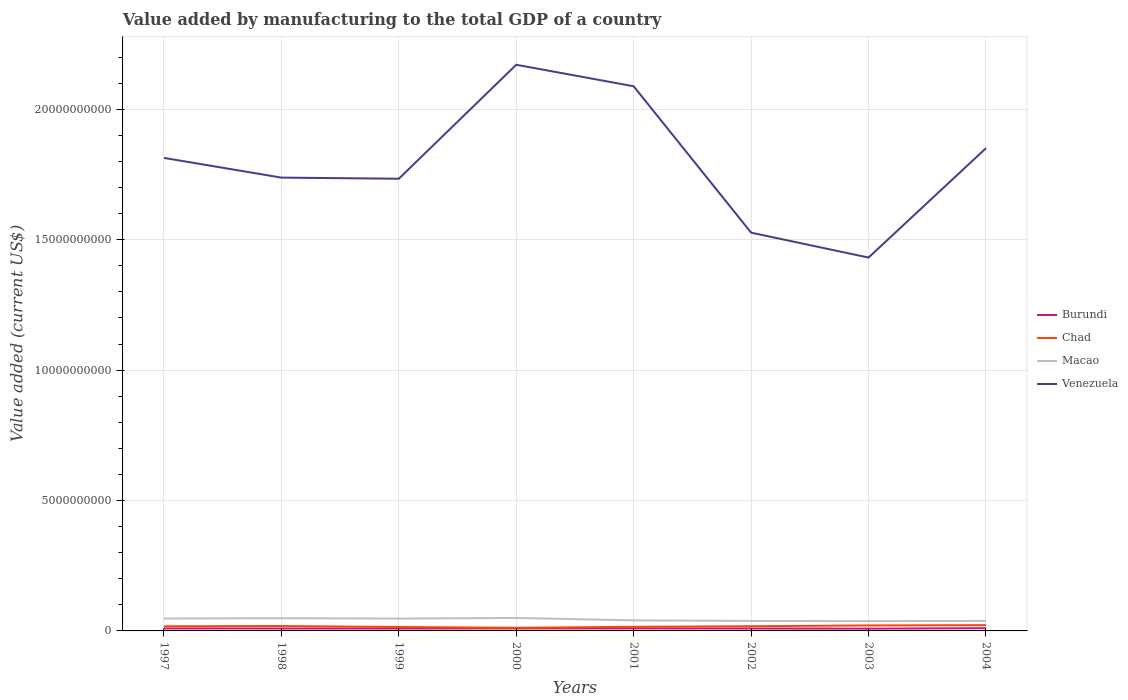Does the line corresponding to Venezuela intersect with the line corresponding to Burundi?
Ensure brevity in your answer.  No. Is the number of lines equal to the number of legend labels?
Ensure brevity in your answer.  Yes. Across all years, what is the maximum value added by manufacturing to the total GDP in Chad?
Your answer should be compact. 1.19e+08. In which year was the value added by manufacturing to the total GDP in Venezuela maximum?
Make the answer very short. 2003. What is the total value added by manufacturing to the total GDP in Macao in the graph?
Provide a short and direct response. 8.84e+07. What is the difference between the highest and the second highest value added by manufacturing to the total GDP in Burundi?
Keep it short and to the point. 1.82e+07. What is the difference between the highest and the lowest value added by manufacturing to the total GDP in Burundi?
Your answer should be compact. 4. How many lines are there?
Make the answer very short. 4. Are the values on the major ticks of Y-axis written in scientific E-notation?
Keep it short and to the point. No. Where does the legend appear in the graph?
Keep it short and to the point. Center right. How are the legend labels stacked?
Make the answer very short. Vertical. What is the title of the graph?
Offer a terse response. Value added by manufacturing to the total GDP of a country. What is the label or title of the Y-axis?
Make the answer very short. Value added (current US$). What is the Value added (current US$) of Burundi in 1997?
Make the answer very short. 9.48e+07. What is the Value added (current US$) of Chad in 1997?
Provide a short and direct response. 1.78e+08. What is the Value added (current US$) in Macao in 1997?
Give a very brief answer. 4.75e+08. What is the Value added (current US$) of Venezuela in 1997?
Your answer should be compact. 1.81e+1. What is the Value added (current US$) of Burundi in 1998?
Keep it short and to the point. 9.21e+07. What is the Value added (current US$) in Chad in 1998?
Provide a succinct answer. 1.88e+08. What is the Value added (current US$) of Macao in 1998?
Provide a short and direct response. 4.88e+08. What is the Value added (current US$) of Venezuela in 1998?
Your answer should be very brief. 1.74e+1. What is the Value added (current US$) in Burundi in 1999?
Your answer should be compact. 9.14e+07. What is the Value added (current US$) in Chad in 1999?
Your answer should be compact. 1.50e+08. What is the Value added (current US$) of Macao in 1999?
Make the answer very short. 4.73e+08. What is the Value added (current US$) of Venezuela in 1999?
Provide a succinct answer. 1.73e+1. What is the Value added (current US$) in Burundi in 2000?
Provide a short and direct response. 9.49e+07. What is the Value added (current US$) in Chad in 2000?
Your answer should be compact. 1.19e+08. What is the Value added (current US$) of Macao in 2000?
Your response must be concise. 4.97e+08. What is the Value added (current US$) in Venezuela in 2000?
Provide a succinct answer. 2.17e+1. What is the Value added (current US$) in Burundi in 2001?
Ensure brevity in your answer.  9.58e+07. What is the Value added (current US$) in Chad in 2001?
Offer a terse response. 1.57e+08. What is the Value added (current US$) of Macao in 2001?
Provide a short and direct response. 4.05e+08. What is the Value added (current US$) of Venezuela in 2001?
Make the answer very short. 2.09e+1. What is the Value added (current US$) of Burundi in 2002?
Your answer should be compact. 9.15e+07. What is the Value added (current US$) in Chad in 2002?
Give a very brief answer. 1.80e+08. What is the Value added (current US$) of Macao in 2002?
Your response must be concise. 3.82e+08. What is the Value added (current US$) in Venezuela in 2002?
Give a very brief answer. 1.53e+1. What is the Value added (current US$) of Burundi in 2003?
Your answer should be compact. 8.66e+07. What is the Value added (current US$) of Chad in 2003?
Your answer should be compact. 2.10e+08. What is the Value added (current US$) of Macao in 2003?
Make the answer very short. 3.75e+08. What is the Value added (current US$) of Venezuela in 2003?
Keep it short and to the point. 1.43e+1. What is the Value added (current US$) in Burundi in 2004?
Offer a very short reply. 1.05e+08. What is the Value added (current US$) of Chad in 2004?
Your answer should be very brief. 2.22e+08. What is the Value added (current US$) of Macao in 2004?
Give a very brief answer. 3.84e+08. What is the Value added (current US$) of Venezuela in 2004?
Your answer should be compact. 1.85e+1. Across all years, what is the maximum Value added (current US$) of Burundi?
Provide a succinct answer. 1.05e+08. Across all years, what is the maximum Value added (current US$) of Chad?
Make the answer very short. 2.22e+08. Across all years, what is the maximum Value added (current US$) of Macao?
Your response must be concise. 4.97e+08. Across all years, what is the maximum Value added (current US$) of Venezuela?
Keep it short and to the point. 2.17e+1. Across all years, what is the minimum Value added (current US$) in Burundi?
Give a very brief answer. 8.66e+07. Across all years, what is the minimum Value added (current US$) of Chad?
Keep it short and to the point. 1.19e+08. Across all years, what is the minimum Value added (current US$) in Macao?
Keep it short and to the point. 3.75e+08. Across all years, what is the minimum Value added (current US$) of Venezuela?
Make the answer very short. 1.43e+1. What is the total Value added (current US$) of Burundi in the graph?
Provide a short and direct response. 7.52e+08. What is the total Value added (current US$) in Chad in the graph?
Your answer should be very brief. 1.40e+09. What is the total Value added (current US$) of Macao in the graph?
Your response must be concise. 3.48e+09. What is the total Value added (current US$) in Venezuela in the graph?
Make the answer very short. 1.44e+11. What is the difference between the Value added (current US$) in Burundi in 1997 and that in 1998?
Give a very brief answer. 2.69e+06. What is the difference between the Value added (current US$) of Chad in 1997 and that in 1998?
Provide a short and direct response. -9.75e+06. What is the difference between the Value added (current US$) of Macao in 1997 and that in 1998?
Ensure brevity in your answer.  -1.30e+07. What is the difference between the Value added (current US$) of Venezuela in 1997 and that in 1998?
Your answer should be very brief. 7.56e+08. What is the difference between the Value added (current US$) of Burundi in 1997 and that in 1999?
Provide a short and direct response. 3.42e+06. What is the difference between the Value added (current US$) in Chad in 1997 and that in 1999?
Your response must be concise. 2.82e+07. What is the difference between the Value added (current US$) in Macao in 1997 and that in 1999?
Your answer should be compact. 1.82e+06. What is the difference between the Value added (current US$) in Venezuela in 1997 and that in 1999?
Provide a short and direct response. 7.99e+08. What is the difference between the Value added (current US$) of Burundi in 1997 and that in 2000?
Keep it short and to the point. -9.14e+04. What is the difference between the Value added (current US$) in Chad in 1997 and that in 2000?
Provide a short and direct response. 5.94e+07. What is the difference between the Value added (current US$) of Macao in 1997 and that in 2000?
Give a very brief answer. -2.24e+07. What is the difference between the Value added (current US$) of Venezuela in 1997 and that in 2000?
Your answer should be compact. -3.57e+09. What is the difference between the Value added (current US$) in Burundi in 1997 and that in 2001?
Keep it short and to the point. -9.86e+05. What is the difference between the Value added (current US$) of Chad in 1997 and that in 2001?
Provide a succinct answer. 2.09e+07. What is the difference between the Value added (current US$) of Macao in 1997 and that in 2001?
Provide a succinct answer. 6.96e+07. What is the difference between the Value added (current US$) in Venezuela in 1997 and that in 2001?
Your answer should be very brief. -2.75e+09. What is the difference between the Value added (current US$) of Burundi in 1997 and that in 2002?
Offer a very short reply. 3.29e+06. What is the difference between the Value added (current US$) of Chad in 1997 and that in 2002?
Keep it short and to the point. -1.81e+06. What is the difference between the Value added (current US$) in Macao in 1997 and that in 2002?
Ensure brevity in your answer.  9.26e+07. What is the difference between the Value added (current US$) in Venezuela in 1997 and that in 2002?
Provide a succinct answer. 2.87e+09. What is the difference between the Value added (current US$) in Burundi in 1997 and that in 2003?
Provide a short and direct response. 8.15e+06. What is the difference between the Value added (current US$) of Chad in 1997 and that in 2003?
Provide a short and direct response. -3.16e+07. What is the difference between the Value added (current US$) of Macao in 1997 and that in 2003?
Keep it short and to the point. 9.95e+07. What is the difference between the Value added (current US$) in Venezuela in 1997 and that in 2003?
Give a very brief answer. 3.82e+09. What is the difference between the Value added (current US$) of Burundi in 1997 and that in 2004?
Provide a succinct answer. -1.00e+07. What is the difference between the Value added (current US$) in Chad in 1997 and that in 2004?
Ensure brevity in your answer.  -4.33e+07. What is the difference between the Value added (current US$) in Macao in 1997 and that in 2004?
Make the answer very short. 9.02e+07. What is the difference between the Value added (current US$) in Venezuela in 1997 and that in 2004?
Ensure brevity in your answer.  -3.71e+08. What is the difference between the Value added (current US$) in Burundi in 1998 and that in 1999?
Provide a succinct answer. 7.35e+05. What is the difference between the Value added (current US$) of Chad in 1998 and that in 1999?
Give a very brief answer. 3.80e+07. What is the difference between the Value added (current US$) in Macao in 1998 and that in 1999?
Give a very brief answer. 1.48e+07. What is the difference between the Value added (current US$) of Venezuela in 1998 and that in 1999?
Provide a succinct answer. 4.28e+07. What is the difference between the Value added (current US$) in Burundi in 1998 and that in 2000?
Your answer should be compact. -2.78e+06. What is the difference between the Value added (current US$) of Chad in 1998 and that in 2000?
Offer a very short reply. 6.91e+07. What is the difference between the Value added (current US$) of Macao in 1998 and that in 2000?
Keep it short and to the point. -9.37e+06. What is the difference between the Value added (current US$) of Venezuela in 1998 and that in 2000?
Offer a terse response. -4.33e+09. What is the difference between the Value added (current US$) of Burundi in 1998 and that in 2001?
Your answer should be very brief. -3.67e+06. What is the difference between the Value added (current US$) in Chad in 1998 and that in 2001?
Offer a very short reply. 3.06e+07. What is the difference between the Value added (current US$) in Macao in 1998 and that in 2001?
Provide a succinct answer. 8.26e+07. What is the difference between the Value added (current US$) in Venezuela in 1998 and that in 2001?
Ensure brevity in your answer.  -3.50e+09. What is the difference between the Value added (current US$) of Burundi in 1998 and that in 2002?
Your answer should be compact. 6.04e+05. What is the difference between the Value added (current US$) of Chad in 1998 and that in 2002?
Keep it short and to the point. 7.94e+06. What is the difference between the Value added (current US$) of Macao in 1998 and that in 2002?
Provide a short and direct response. 1.06e+08. What is the difference between the Value added (current US$) of Venezuela in 1998 and that in 2002?
Keep it short and to the point. 2.11e+09. What is the difference between the Value added (current US$) in Burundi in 1998 and that in 2003?
Your answer should be compact. 5.46e+06. What is the difference between the Value added (current US$) of Chad in 1998 and that in 2003?
Offer a terse response. -2.19e+07. What is the difference between the Value added (current US$) of Macao in 1998 and that in 2003?
Offer a very short reply. 1.12e+08. What is the difference between the Value added (current US$) in Venezuela in 1998 and that in 2003?
Keep it short and to the point. 3.07e+09. What is the difference between the Value added (current US$) in Burundi in 1998 and that in 2004?
Offer a terse response. -1.27e+07. What is the difference between the Value added (current US$) of Chad in 1998 and that in 2004?
Make the answer very short. -3.36e+07. What is the difference between the Value added (current US$) of Macao in 1998 and that in 2004?
Make the answer very short. 1.03e+08. What is the difference between the Value added (current US$) of Venezuela in 1998 and that in 2004?
Offer a terse response. -1.13e+09. What is the difference between the Value added (current US$) of Burundi in 1999 and that in 2000?
Your response must be concise. -3.52e+06. What is the difference between the Value added (current US$) of Chad in 1999 and that in 2000?
Your response must be concise. 3.12e+07. What is the difference between the Value added (current US$) in Macao in 1999 and that in 2000?
Your answer should be compact. -2.42e+07. What is the difference between the Value added (current US$) in Venezuela in 1999 and that in 2000?
Provide a succinct answer. -4.37e+09. What is the difference between the Value added (current US$) in Burundi in 1999 and that in 2001?
Your answer should be very brief. -4.41e+06. What is the difference between the Value added (current US$) in Chad in 1999 and that in 2001?
Provide a short and direct response. -7.35e+06. What is the difference between the Value added (current US$) in Macao in 1999 and that in 2001?
Offer a very short reply. 6.78e+07. What is the difference between the Value added (current US$) in Venezuela in 1999 and that in 2001?
Ensure brevity in your answer.  -3.54e+09. What is the difference between the Value added (current US$) in Burundi in 1999 and that in 2002?
Offer a very short reply. -1.31e+05. What is the difference between the Value added (current US$) of Chad in 1999 and that in 2002?
Make the answer very short. -3.00e+07. What is the difference between the Value added (current US$) in Macao in 1999 and that in 2002?
Your answer should be very brief. 9.07e+07. What is the difference between the Value added (current US$) of Venezuela in 1999 and that in 2002?
Provide a short and direct response. 2.07e+09. What is the difference between the Value added (current US$) in Burundi in 1999 and that in 2003?
Provide a succinct answer. 4.73e+06. What is the difference between the Value added (current US$) in Chad in 1999 and that in 2003?
Your answer should be very brief. -5.98e+07. What is the difference between the Value added (current US$) in Macao in 1999 and that in 2003?
Provide a short and direct response. 9.76e+07. What is the difference between the Value added (current US$) in Venezuela in 1999 and that in 2003?
Offer a very short reply. 3.02e+09. What is the difference between the Value added (current US$) in Burundi in 1999 and that in 2004?
Offer a terse response. -1.34e+07. What is the difference between the Value added (current US$) of Chad in 1999 and that in 2004?
Your answer should be very brief. -7.16e+07. What is the difference between the Value added (current US$) in Macao in 1999 and that in 2004?
Your answer should be very brief. 8.84e+07. What is the difference between the Value added (current US$) of Venezuela in 1999 and that in 2004?
Keep it short and to the point. -1.17e+09. What is the difference between the Value added (current US$) of Burundi in 2000 and that in 2001?
Provide a short and direct response. -8.95e+05. What is the difference between the Value added (current US$) of Chad in 2000 and that in 2001?
Offer a terse response. -3.85e+07. What is the difference between the Value added (current US$) in Macao in 2000 and that in 2001?
Your answer should be compact. 9.20e+07. What is the difference between the Value added (current US$) of Venezuela in 2000 and that in 2001?
Offer a very short reply. 8.25e+08. What is the difference between the Value added (current US$) in Burundi in 2000 and that in 2002?
Offer a very short reply. 3.38e+06. What is the difference between the Value added (current US$) in Chad in 2000 and that in 2002?
Your answer should be compact. -6.12e+07. What is the difference between the Value added (current US$) of Macao in 2000 and that in 2002?
Your answer should be compact. 1.15e+08. What is the difference between the Value added (current US$) of Venezuela in 2000 and that in 2002?
Keep it short and to the point. 6.44e+09. What is the difference between the Value added (current US$) in Burundi in 2000 and that in 2003?
Your answer should be compact. 8.24e+06. What is the difference between the Value added (current US$) in Chad in 2000 and that in 2003?
Offer a terse response. -9.10e+07. What is the difference between the Value added (current US$) in Macao in 2000 and that in 2003?
Give a very brief answer. 1.22e+08. What is the difference between the Value added (current US$) of Venezuela in 2000 and that in 2003?
Ensure brevity in your answer.  7.39e+09. What is the difference between the Value added (current US$) in Burundi in 2000 and that in 2004?
Keep it short and to the point. -9.91e+06. What is the difference between the Value added (current US$) in Chad in 2000 and that in 2004?
Ensure brevity in your answer.  -1.03e+08. What is the difference between the Value added (current US$) of Macao in 2000 and that in 2004?
Offer a terse response. 1.13e+08. What is the difference between the Value added (current US$) of Venezuela in 2000 and that in 2004?
Provide a succinct answer. 3.20e+09. What is the difference between the Value added (current US$) of Burundi in 2001 and that in 2002?
Ensure brevity in your answer.  4.28e+06. What is the difference between the Value added (current US$) of Chad in 2001 and that in 2002?
Offer a very short reply. -2.27e+07. What is the difference between the Value added (current US$) in Macao in 2001 and that in 2002?
Provide a succinct answer. 2.30e+07. What is the difference between the Value added (current US$) in Venezuela in 2001 and that in 2002?
Offer a very short reply. 5.61e+09. What is the difference between the Value added (current US$) in Burundi in 2001 and that in 2003?
Ensure brevity in your answer.  9.14e+06. What is the difference between the Value added (current US$) in Chad in 2001 and that in 2003?
Offer a very short reply. -5.25e+07. What is the difference between the Value added (current US$) of Macao in 2001 and that in 2003?
Make the answer very short. 2.99e+07. What is the difference between the Value added (current US$) in Venezuela in 2001 and that in 2003?
Offer a very short reply. 6.57e+09. What is the difference between the Value added (current US$) of Burundi in 2001 and that in 2004?
Your answer should be compact. -9.02e+06. What is the difference between the Value added (current US$) in Chad in 2001 and that in 2004?
Keep it short and to the point. -6.42e+07. What is the difference between the Value added (current US$) of Macao in 2001 and that in 2004?
Offer a very short reply. 2.06e+07. What is the difference between the Value added (current US$) of Venezuela in 2001 and that in 2004?
Keep it short and to the point. 2.37e+09. What is the difference between the Value added (current US$) in Burundi in 2002 and that in 2003?
Your response must be concise. 4.86e+06. What is the difference between the Value added (current US$) of Chad in 2002 and that in 2003?
Ensure brevity in your answer.  -2.98e+07. What is the difference between the Value added (current US$) in Macao in 2002 and that in 2003?
Your answer should be very brief. 6.90e+06. What is the difference between the Value added (current US$) in Venezuela in 2002 and that in 2003?
Provide a short and direct response. 9.55e+08. What is the difference between the Value added (current US$) of Burundi in 2002 and that in 2004?
Make the answer very short. -1.33e+07. What is the difference between the Value added (current US$) in Chad in 2002 and that in 2004?
Your response must be concise. -4.15e+07. What is the difference between the Value added (current US$) of Macao in 2002 and that in 2004?
Ensure brevity in your answer.  -2.38e+06. What is the difference between the Value added (current US$) in Venezuela in 2002 and that in 2004?
Provide a succinct answer. -3.24e+09. What is the difference between the Value added (current US$) of Burundi in 2003 and that in 2004?
Your answer should be very brief. -1.82e+07. What is the difference between the Value added (current US$) of Chad in 2003 and that in 2004?
Make the answer very short. -1.17e+07. What is the difference between the Value added (current US$) in Macao in 2003 and that in 2004?
Offer a terse response. -9.28e+06. What is the difference between the Value added (current US$) in Venezuela in 2003 and that in 2004?
Your response must be concise. -4.19e+09. What is the difference between the Value added (current US$) of Burundi in 1997 and the Value added (current US$) of Chad in 1998?
Ensure brevity in your answer.  -9.33e+07. What is the difference between the Value added (current US$) of Burundi in 1997 and the Value added (current US$) of Macao in 1998?
Offer a very short reply. -3.93e+08. What is the difference between the Value added (current US$) of Burundi in 1997 and the Value added (current US$) of Venezuela in 1998?
Offer a very short reply. -1.73e+1. What is the difference between the Value added (current US$) of Chad in 1997 and the Value added (current US$) of Macao in 1998?
Provide a short and direct response. -3.09e+08. What is the difference between the Value added (current US$) in Chad in 1997 and the Value added (current US$) in Venezuela in 1998?
Keep it short and to the point. -1.72e+1. What is the difference between the Value added (current US$) of Macao in 1997 and the Value added (current US$) of Venezuela in 1998?
Keep it short and to the point. -1.69e+1. What is the difference between the Value added (current US$) in Burundi in 1997 and the Value added (current US$) in Chad in 1999?
Offer a very short reply. -5.53e+07. What is the difference between the Value added (current US$) in Burundi in 1997 and the Value added (current US$) in Macao in 1999?
Provide a succinct answer. -3.78e+08. What is the difference between the Value added (current US$) of Burundi in 1997 and the Value added (current US$) of Venezuela in 1999?
Ensure brevity in your answer.  -1.72e+1. What is the difference between the Value added (current US$) in Chad in 1997 and the Value added (current US$) in Macao in 1999?
Keep it short and to the point. -2.94e+08. What is the difference between the Value added (current US$) of Chad in 1997 and the Value added (current US$) of Venezuela in 1999?
Your answer should be compact. -1.72e+1. What is the difference between the Value added (current US$) in Macao in 1997 and the Value added (current US$) in Venezuela in 1999?
Offer a terse response. -1.69e+1. What is the difference between the Value added (current US$) in Burundi in 1997 and the Value added (current US$) in Chad in 2000?
Provide a succinct answer. -2.41e+07. What is the difference between the Value added (current US$) of Burundi in 1997 and the Value added (current US$) of Macao in 2000?
Ensure brevity in your answer.  -4.02e+08. What is the difference between the Value added (current US$) of Burundi in 1997 and the Value added (current US$) of Venezuela in 2000?
Offer a very short reply. -2.16e+1. What is the difference between the Value added (current US$) in Chad in 1997 and the Value added (current US$) in Macao in 2000?
Give a very brief answer. -3.19e+08. What is the difference between the Value added (current US$) of Chad in 1997 and the Value added (current US$) of Venezuela in 2000?
Make the answer very short. -2.15e+1. What is the difference between the Value added (current US$) of Macao in 1997 and the Value added (current US$) of Venezuela in 2000?
Give a very brief answer. -2.12e+1. What is the difference between the Value added (current US$) in Burundi in 1997 and the Value added (current US$) in Chad in 2001?
Your answer should be very brief. -6.27e+07. What is the difference between the Value added (current US$) of Burundi in 1997 and the Value added (current US$) of Macao in 2001?
Provide a short and direct response. -3.10e+08. What is the difference between the Value added (current US$) of Burundi in 1997 and the Value added (current US$) of Venezuela in 2001?
Keep it short and to the point. -2.08e+1. What is the difference between the Value added (current US$) in Chad in 1997 and the Value added (current US$) in Macao in 2001?
Provide a short and direct response. -2.27e+08. What is the difference between the Value added (current US$) of Chad in 1997 and the Value added (current US$) of Venezuela in 2001?
Offer a very short reply. -2.07e+1. What is the difference between the Value added (current US$) of Macao in 1997 and the Value added (current US$) of Venezuela in 2001?
Keep it short and to the point. -2.04e+1. What is the difference between the Value added (current US$) of Burundi in 1997 and the Value added (current US$) of Chad in 2002?
Provide a succinct answer. -8.53e+07. What is the difference between the Value added (current US$) of Burundi in 1997 and the Value added (current US$) of Macao in 2002?
Make the answer very short. -2.87e+08. What is the difference between the Value added (current US$) in Burundi in 1997 and the Value added (current US$) in Venezuela in 2002?
Provide a succinct answer. -1.52e+1. What is the difference between the Value added (current US$) in Chad in 1997 and the Value added (current US$) in Macao in 2002?
Offer a very short reply. -2.04e+08. What is the difference between the Value added (current US$) in Chad in 1997 and the Value added (current US$) in Venezuela in 2002?
Provide a succinct answer. -1.51e+1. What is the difference between the Value added (current US$) of Macao in 1997 and the Value added (current US$) of Venezuela in 2002?
Make the answer very short. -1.48e+1. What is the difference between the Value added (current US$) of Burundi in 1997 and the Value added (current US$) of Chad in 2003?
Provide a succinct answer. -1.15e+08. What is the difference between the Value added (current US$) of Burundi in 1997 and the Value added (current US$) of Macao in 2003?
Provide a short and direct response. -2.80e+08. What is the difference between the Value added (current US$) of Burundi in 1997 and the Value added (current US$) of Venezuela in 2003?
Ensure brevity in your answer.  -1.42e+1. What is the difference between the Value added (current US$) of Chad in 1997 and the Value added (current US$) of Macao in 2003?
Keep it short and to the point. -1.97e+08. What is the difference between the Value added (current US$) of Chad in 1997 and the Value added (current US$) of Venezuela in 2003?
Provide a succinct answer. -1.41e+1. What is the difference between the Value added (current US$) of Macao in 1997 and the Value added (current US$) of Venezuela in 2003?
Make the answer very short. -1.38e+1. What is the difference between the Value added (current US$) in Burundi in 1997 and the Value added (current US$) in Chad in 2004?
Ensure brevity in your answer.  -1.27e+08. What is the difference between the Value added (current US$) of Burundi in 1997 and the Value added (current US$) of Macao in 2004?
Give a very brief answer. -2.90e+08. What is the difference between the Value added (current US$) in Burundi in 1997 and the Value added (current US$) in Venezuela in 2004?
Your answer should be compact. -1.84e+1. What is the difference between the Value added (current US$) of Chad in 1997 and the Value added (current US$) of Macao in 2004?
Provide a short and direct response. -2.06e+08. What is the difference between the Value added (current US$) of Chad in 1997 and the Value added (current US$) of Venezuela in 2004?
Provide a short and direct response. -1.83e+1. What is the difference between the Value added (current US$) in Macao in 1997 and the Value added (current US$) in Venezuela in 2004?
Offer a terse response. -1.80e+1. What is the difference between the Value added (current US$) of Burundi in 1998 and the Value added (current US$) of Chad in 1999?
Your answer should be compact. -5.80e+07. What is the difference between the Value added (current US$) in Burundi in 1998 and the Value added (current US$) in Macao in 1999?
Your answer should be very brief. -3.81e+08. What is the difference between the Value added (current US$) in Burundi in 1998 and the Value added (current US$) in Venezuela in 1999?
Ensure brevity in your answer.  -1.72e+1. What is the difference between the Value added (current US$) in Chad in 1998 and the Value added (current US$) in Macao in 1999?
Provide a short and direct response. -2.85e+08. What is the difference between the Value added (current US$) of Chad in 1998 and the Value added (current US$) of Venezuela in 1999?
Offer a very short reply. -1.71e+1. What is the difference between the Value added (current US$) in Macao in 1998 and the Value added (current US$) in Venezuela in 1999?
Your response must be concise. -1.68e+1. What is the difference between the Value added (current US$) of Burundi in 1998 and the Value added (current US$) of Chad in 2000?
Offer a terse response. -2.68e+07. What is the difference between the Value added (current US$) of Burundi in 1998 and the Value added (current US$) of Macao in 2000?
Offer a terse response. -4.05e+08. What is the difference between the Value added (current US$) in Burundi in 1998 and the Value added (current US$) in Venezuela in 2000?
Provide a succinct answer. -2.16e+1. What is the difference between the Value added (current US$) of Chad in 1998 and the Value added (current US$) of Macao in 2000?
Offer a very short reply. -3.09e+08. What is the difference between the Value added (current US$) in Chad in 1998 and the Value added (current US$) in Venezuela in 2000?
Keep it short and to the point. -2.15e+1. What is the difference between the Value added (current US$) of Macao in 1998 and the Value added (current US$) of Venezuela in 2000?
Offer a very short reply. -2.12e+1. What is the difference between the Value added (current US$) of Burundi in 1998 and the Value added (current US$) of Chad in 2001?
Offer a very short reply. -6.53e+07. What is the difference between the Value added (current US$) of Burundi in 1998 and the Value added (current US$) of Macao in 2001?
Your answer should be very brief. -3.13e+08. What is the difference between the Value added (current US$) of Burundi in 1998 and the Value added (current US$) of Venezuela in 2001?
Ensure brevity in your answer.  -2.08e+1. What is the difference between the Value added (current US$) in Chad in 1998 and the Value added (current US$) in Macao in 2001?
Give a very brief answer. -2.17e+08. What is the difference between the Value added (current US$) of Chad in 1998 and the Value added (current US$) of Venezuela in 2001?
Give a very brief answer. -2.07e+1. What is the difference between the Value added (current US$) of Macao in 1998 and the Value added (current US$) of Venezuela in 2001?
Your answer should be compact. -2.04e+1. What is the difference between the Value added (current US$) of Burundi in 1998 and the Value added (current US$) of Chad in 2002?
Make the answer very short. -8.80e+07. What is the difference between the Value added (current US$) in Burundi in 1998 and the Value added (current US$) in Macao in 2002?
Offer a terse response. -2.90e+08. What is the difference between the Value added (current US$) in Burundi in 1998 and the Value added (current US$) in Venezuela in 2002?
Your response must be concise. -1.52e+1. What is the difference between the Value added (current US$) in Chad in 1998 and the Value added (current US$) in Macao in 2002?
Offer a terse response. -1.94e+08. What is the difference between the Value added (current US$) in Chad in 1998 and the Value added (current US$) in Venezuela in 2002?
Provide a succinct answer. -1.51e+1. What is the difference between the Value added (current US$) in Macao in 1998 and the Value added (current US$) in Venezuela in 2002?
Ensure brevity in your answer.  -1.48e+1. What is the difference between the Value added (current US$) in Burundi in 1998 and the Value added (current US$) in Chad in 2003?
Offer a very short reply. -1.18e+08. What is the difference between the Value added (current US$) of Burundi in 1998 and the Value added (current US$) of Macao in 2003?
Ensure brevity in your answer.  -2.83e+08. What is the difference between the Value added (current US$) of Burundi in 1998 and the Value added (current US$) of Venezuela in 2003?
Provide a succinct answer. -1.42e+1. What is the difference between the Value added (current US$) in Chad in 1998 and the Value added (current US$) in Macao in 2003?
Your answer should be compact. -1.87e+08. What is the difference between the Value added (current US$) in Chad in 1998 and the Value added (current US$) in Venezuela in 2003?
Make the answer very short. -1.41e+1. What is the difference between the Value added (current US$) in Macao in 1998 and the Value added (current US$) in Venezuela in 2003?
Offer a very short reply. -1.38e+1. What is the difference between the Value added (current US$) of Burundi in 1998 and the Value added (current US$) of Chad in 2004?
Offer a very short reply. -1.30e+08. What is the difference between the Value added (current US$) in Burundi in 1998 and the Value added (current US$) in Macao in 2004?
Your answer should be compact. -2.92e+08. What is the difference between the Value added (current US$) of Burundi in 1998 and the Value added (current US$) of Venezuela in 2004?
Provide a short and direct response. -1.84e+1. What is the difference between the Value added (current US$) in Chad in 1998 and the Value added (current US$) in Macao in 2004?
Your response must be concise. -1.96e+08. What is the difference between the Value added (current US$) of Chad in 1998 and the Value added (current US$) of Venezuela in 2004?
Provide a short and direct response. -1.83e+1. What is the difference between the Value added (current US$) in Macao in 1998 and the Value added (current US$) in Venezuela in 2004?
Your answer should be compact. -1.80e+1. What is the difference between the Value added (current US$) in Burundi in 1999 and the Value added (current US$) in Chad in 2000?
Provide a short and direct response. -2.76e+07. What is the difference between the Value added (current US$) in Burundi in 1999 and the Value added (current US$) in Macao in 2000?
Give a very brief answer. -4.06e+08. What is the difference between the Value added (current US$) in Burundi in 1999 and the Value added (current US$) in Venezuela in 2000?
Give a very brief answer. -2.16e+1. What is the difference between the Value added (current US$) in Chad in 1999 and the Value added (current US$) in Macao in 2000?
Ensure brevity in your answer.  -3.47e+08. What is the difference between the Value added (current US$) in Chad in 1999 and the Value added (current US$) in Venezuela in 2000?
Offer a very short reply. -2.16e+1. What is the difference between the Value added (current US$) of Macao in 1999 and the Value added (current US$) of Venezuela in 2000?
Your answer should be very brief. -2.12e+1. What is the difference between the Value added (current US$) in Burundi in 1999 and the Value added (current US$) in Chad in 2001?
Give a very brief answer. -6.61e+07. What is the difference between the Value added (current US$) of Burundi in 1999 and the Value added (current US$) of Macao in 2001?
Ensure brevity in your answer.  -3.14e+08. What is the difference between the Value added (current US$) of Burundi in 1999 and the Value added (current US$) of Venezuela in 2001?
Your answer should be very brief. -2.08e+1. What is the difference between the Value added (current US$) of Chad in 1999 and the Value added (current US$) of Macao in 2001?
Offer a very short reply. -2.55e+08. What is the difference between the Value added (current US$) in Chad in 1999 and the Value added (current US$) in Venezuela in 2001?
Make the answer very short. -2.07e+1. What is the difference between the Value added (current US$) in Macao in 1999 and the Value added (current US$) in Venezuela in 2001?
Offer a very short reply. -2.04e+1. What is the difference between the Value added (current US$) in Burundi in 1999 and the Value added (current US$) in Chad in 2002?
Your response must be concise. -8.87e+07. What is the difference between the Value added (current US$) in Burundi in 1999 and the Value added (current US$) in Macao in 2002?
Your answer should be very brief. -2.91e+08. What is the difference between the Value added (current US$) in Burundi in 1999 and the Value added (current US$) in Venezuela in 2002?
Your answer should be compact. -1.52e+1. What is the difference between the Value added (current US$) of Chad in 1999 and the Value added (current US$) of Macao in 2002?
Provide a succinct answer. -2.32e+08. What is the difference between the Value added (current US$) in Chad in 1999 and the Value added (current US$) in Venezuela in 2002?
Offer a terse response. -1.51e+1. What is the difference between the Value added (current US$) in Macao in 1999 and the Value added (current US$) in Venezuela in 2002?
Give a very brief answer. -1.48e+1. What is the difference between the Value added (current US$) of Burundi in 1999 and the Value added (current US$) of Chad in 2003?
Ensure brevity in your answer.  -1.19e+08. What is the difference between the Value added (current US$) of Burundi in 1999 and the Value added (current US$) of Macao in 2003?
Make the answer very short. -2.84e+08. What is the difference between the Value added (current US$) in Burundi in 1999 and the Value added (current US$) in Venezuela in 2003?
Ensure brevity in your answer.  -1.42e+1. What is the difference between the Value added (current US$) of Chad in 1999 and the Value added (current US$) of Macao in 2003?
Your answer should be very brief. -2.25e+08. What is the difference between the Value added (current US$) of Chad in 1999 and the Value added (current US$) of Venezuela in 2003?
Provide a succinct answer. -1.42e+1. What is the difference between the Value added (current US$) of Macao in 1999 and the Value added (current US$) of Venezuela in 2003?
Offer a very short reply. -1.38e+1. What is the difference between the Value added (current US$) of Burundi in 1999 and the Value added (current US$) of Chad in 2004?
Your answer should be compact. -1.30e+08. What is the difference between the Value added (current US$) of Burundi in 1999 and the Value added (current US$) of Macao in 2004?
Keep it short and to the point. -2.93e+08. What is the difference between the Value added (current US$) in Burundi in 1999 and the Value added (current US$) in Venezuela in 2004?
Provide a succinct answer. -1.84e+1. What is the difference between the Value added (current US$) in Chad in 1999 and the Value added (current US$) in Macao in 2004?
Give a very brief answer. -2.34e+08. What is the difference between the Value added (current US$) in Chad in 1999 and the Value added (current US$) in Venezuela in 2004?
Your answer should be compact. -1.84e+1. What is the difference between the Value added (current US$) in Macao in 1999 and the Value added (current US$) in Venezuela in 2004?
Your answer should be compact. -1.80e+1. What is the difference between the Value added (current US$) of Burundi in 2000 and the Value added (current US$) of Chad in 2001?
Offer a very short reply. -6.26e+07. What is the difference between the Value added (current US$) in Burundi in 2000 and the Value added (current US$) in Macao in 2001?
Offer a very short reply. -3.10e+08. What is the difference between the Value added (current US$) of Burundi in 2000 and the Value added (current US$) of Venezuela in 2001?
Give a very brief answer. -2.08e+1. What is the difference between the Value added (current US$) in Chad in 2000 and the Value added (current US$) in Macao in 2001?
Your answer should be very brief. -2.86e+08. What is the difference between the Value added (current US$) in Chad in 2000 and the Value added (current US$) in Venezuela in 2001?
Ensure brevity in your answer.  -2.08e+1. What is the difference between the Value added (current US$) of Macao in 2000 and the Value added (current US$) of Venezuela in 2001?
Make the answer very short. -2.04e+1. What is the difference between the Value added (current US$) of Burundi in 2000 and the Value added (current US$) of Chad in 2002?
Your response must be concise. -8.52e+07. What is the difference between the Value added (current US$) of Burundi in 2000 and the Value added (current US$) of Macao in 2002?
Provide a succinct answer. -2.87e+08. What is the difference between the Value added (current US$) of Burundi in 2000 and the Value added (current US$) of Venezuela in 2002?
Make the answer very short. -1.52e+1. What is the difference between the Value added (current US$) of Chad in 2000 and the Value added (current US$) of Macao in 2002?
Keep it short and to the point. -2.63e+08. What is the difference between the Value added (current US$) of Chad in 2000 and the Value added (current US$) of Venezuela in 2002?
Your answer should be compact. -1.52e+1. What is the difference between the Value added (current US$) in Macao in 2000 and the Value added (current US$) in Venezuela in 2002?
Make the answer very short. -1.48e+1. What is the difference between the Value added (current US$) in Burundi in 2000 and the Value added (current US$) in Chad in 2003?
Offer a terse response. -1.15e+08. What is the difference between the Value added (current US$) of Burundi in 2000 and the Value added (current US$) of Macao in 2003?
Provide a succinct answer. -2.80e+08. What is the difference between the Value added (current US$) in Burundi in 2000 and the Value added (current US$) in Venezuela in 2003?
Your response must be concise. -1.42e+1. What is the difference between the Value added (current US$) of Chad in 2000 and the Value added (current US$) of Macao in 2003?
Provide a succinct answer. -2.56e+08. What is the difference between the Value added (current US$) in Chad in 2000 and the Value added (current US$) in Venezuela in 2003?
Make the answer very short. -1.42e+1. What is the difference between the Value added (current US$) in Macao in 2000 and the Value added (current US$) in Venezuela in 2003?
Provide a short and direct response. -1.38e+1. What is the difference between the Value added (current US$) in Burundi in 2000 and the Value added (current US$) in Chad in 2004?
Ensure brevity in your answer.  -1.27e+08. What is the difference between the Value added (current US$) in Burundi in 2000 and the Value added (current US$) in Macao in 2004?
Your response must be concise. -2.90e+08. What is the difference between the Value added (current US$) in Burundi in 2000 and the Value added (current US$) in Venezuela in 2004?
Offer a very short reply. -1.84e+1. What is the difference between the Value added (current US$) of Chad in 2000 and the Value added (current US$) of Macao in 2004?
Offer a terse response. -2.65e+08. What is the difference between the Value added (current US$) in Chad in 2000 and the Value added (current US$) in Venezuela in 2004?
Give a very brief answer. -1.84e+1. What is the difference between the Value added (current US$) of Macao in 2000 and the Value added (current US$) of Venezuela in 2004?
Your response must be concise. -1.80e+1. What is the difference between the Value added (current US$) in Burundi in 2001 and the Value added (current US$) in Chad in 2002?
Offer a terse response. -8.43e+07. What is the difference between the Value added (current US$) in Burundi in 2001 and the Value added (current US$) in Macao in 2002?
Make the answer very short. -2.86e+08. What is the difference between the Value added (current US$) of Burundi in 2001 and the Value added (current US$) of Venezuela in 2002?
Offer a very short reply. -1.52e+1. What is the difference between the Value added (current US$) of Chad in 2001 and the Value added (current US$) of Macao in 2002?
Your answer should be compact. -2.25e+08. What is the difference between the Value added (current US$) of Chad in 2001 and the Value added (current US$) of Venezuela in 2002?
Ensure brevity in your answer.  -1.51e+1. What is the difference between the Value added (current US$) in Macao in 2001 and the Value added (current US$) in Venezuela in 2002?
Your response must be concise. -1.49e+1. What is the difference between the Value added (current US$) of Burundi in 2001 and the Value added (current US$) of Chad in 2003?
Offer a very short reply. -1.14e+08. What is the difference between the Value added (current US$) of Burundi in 2001 and the Value added (current US$) of Macao in 2003?
Offer a terse response. -2.79e+08. What is the difference between the Value added (current US$) of Burundi in 2001 and the Value added (current US$) of Venezuela in 2003?
Offer a very short reply. -1.42e+1. What is the difference between the Value added (current US$) in Chad in 2001 and the Value added (current US$) in Macao in 2003?
Offer a terse response. -2.18e+08. What is the difference between the Value added (current US$) of Chad in 2001 and the Value added (current US$) of Venezuela in 2003?
Your response must be concise. -1.42e+1. What is the difference between the Value added (current US$) in Macao in 2001 and the Value added (current US$) in Venezuela in 2003?
Your answer should be very brief. -1.39e+1. What is the difference between the Value added (current US$) of Burundi in 2001 and the Value added (current US$) of Chad in 2004?
Give a very brief answer. -1.26e+08. What is the difference between the Value added (current US$) of Burundi in 2001 and the Value added (current US$) of Macao in 2004?
Keep it short and to the point. -2.89e+08. What is the difference between the Value added (current US$) in Burundi in 2001 and the Value added (current US$) in Venezuela in 2004?
Ensure brevity in your answer.  -1.84e+1. What is the difference between the Value added (current US$) in Chad in 2001 and the Value added (current US$) in Macao in 2004?
Provide a succinct answer. -2.27e+08. What is the difference between the Value added (current US$) in Chad in 2001 and the Value added (current US$) in Venezuela in 2004?
Give a very brief answer. -1.83e+1. What is the difference between the Value added (current US$) in Macao in 2001 and the Value added (current US$) in Venezuela in 2004?
Offer a terse response. -1.81e+1. What is the difference between the Value added (current US$) of Burundi in 2002 and the Value added (current US$) of Chad in 2003?
Your response must be concise. -1.18e+08. What is the difference between the Value added (current US$) of Burundi in 2002 and the Value added (current US$) of Macao in 2003?
Your answer should be compact. -2.84e+08. What is the difference between the Value added (current US$) in Burundi in 2002 and the Value added (current US$) in Venezuela in 2003?
Provide a succinct answer. -1.42e+1. What is the difference between the Value added (current US$) in Chad in 2002 and the Value added (current US$) in Macao in 2003?
Make the answer very short. -1.95e+08. What is the difference between the Value added (current US$) in Chad in 2002 and the Value added (current US$) in Venezuela in 2003?
Offer a very short reply. -1.41e+1. What is the difference between the Value added (current US$) in Macao in 2002 and the Value added (current US$) in Venezuela in 2003?
Your answer should be very brief. -1.39e+1. What is the difference between the Value added (current US$) in Burundi in 2002 and the Value added (current US$) in Chad in 2004?
Offer a terse response. -1.30e+08. What is the difference between the Value added (current US$) in Burundi in 2002 and the Value added (current US$) in Macao in 2004?
Give a very brief answer. -2.93e+08. What is the difference between the Value added (current US$) of Burundi in 2002 and the Value added (current US$) of Venezuela in 2004?
Ensure brevity in your answer.  -1.84e+1. What is the difference between the Value added (current US$) of Chad in 2002 and the Value added (current US$) of Macao in 2004?
Ensure brevity in your answer.  -2.04e+08. What is the difference between the Value added (current US$) in Chad in 2002 and the Value added (current US$) in Venezuela in 2004?
Ensure brevity in your answer.  -1.83e+1. What is the difference between the Value added (current US$) in Macao in 2002 and the Value added (current US$) in Venezuela in 2004?
Ensure brevity in your answer.  -1.81e+1. What is the difference between the Value added (current US$) of Burundi in 2003 and the Value added (current US$) of Chad in 2004?
Your answer should be very brief. -1.35e+08. What is the difference between the Value added (current US$) of Burundi in 2003 and the Value added (current US$) of Macao in 2004?
Ensure brevity in your answer.  -2.98e+08. What is the difference between the Value added (current US$) of Burundi in 2003 and the Value added (current US$) of Venezuela in 2004?
Provide a short and direct response. -1.84e+1. What is the difference between the Value added (current US$) in Chad in 2003 and the Value added (current US$) in Macao in 2004?
Offer a very short reply. -1.74e+08. What is the difference between the Value added (current US$) of Chad in 2003 and the Value added (current US$) of Venezuela in 2004?
Your answer should be compact. -1.83e+1. What is the difference between the Value added (current US$) in Macao in 2003 and the Value added (current US$) in Venezuela in 2004?
Give a very brief answer. -1.81e+1. What is the average Value added (current US$) in Burundi per year?
Offer a very short reply. 9.40e+07. What is the average Value added (current US$) in Chad per year?
Your answer should be very brief. 1.76e+08. What is the average Value added (current US$) of Macao per year?
Your response must be concise. 4.35e+08. What is the average Value added (current US$) of Venezuela per year?
Give a very brief answer. 1.79e+1. In the year 1997, what is the difference between the Value added (current US$) in Burundi and Value added (current US$) in Chad?
Offer a very short reply. -8.35e+07. In the year 1997, what is the difference between the Value added (current US$) in Burundi and Value added (current US$) in Macao?
Give a very brief answer. -3.80e+08. In the year 1997, what is the difference between the Value added (current US$) in Burundi and Value added (current US$) in Venezuela?
Ensure brevity in your answer.  -1.80e+1. In the year 1997, what is the difference between the Value added (current US$) of Chad and Value added (current US$) of Macao?
Offer a terse response. -2.96e+08. In the year 1997, what is the difference between the Value added (current US$) of Chad and Value added (current US$) of Venezuela?
Provide a short and direct response. -1.80e+1. In the year 1997, what is the difference between the Value added (current US$) of Macao and Value added (current US$) of Venezuela?
Provide a succinct answer. -1.77e+1. In the year 1998, what is the difference between the Value added (current US$) of Burundi and Value added (current US$) of Chad?
Ensure brevity in your answer.  -9.59e+07. In the year 1998, what is the difference between the Value added (current US$) of Burundi and Value added (current US$) of Macao?
Provide a short and direct response. -3.96e+08. In the year 1998, what is the difference between the Value added (current US$) of Burundi and Value added (current US$) of Venezuela?
Ensure brevity in your answer.  -1.73e+1. In the year 1998, what is the difference between the Value added (current US$) in Chad and Value added (current US$) in Macao?
Offer a very short reply. -3.00e+08. In the year 1998, what is the difference between the Value added (current US$) in Chad and Value added (current US$) in Venezuela?
Provide a succinct answer. -1.72e+1. In the year 1998, what is the difference between the Value added (current US$) of Macao and Value added (current US$) of Venezuela?
Give a very brief answer. -1.69e+1. In the year 1999, what is the difference between the Value added (current US$) of Burundi and Value added (current US$) of Chad?
Your response must be concise. -5.87e+07. In the year 1999, what is the difference between the Value added (current US$) in Burundi and Value added (current US$) in Macao?
Your answer should be compact. -3.81e+08. In the year 1999, what is the difference between the Value added (current US$) of Burundi and Value added (current US$) of Venezuela?
Ensure brevity in your answer.  -1.72e+1. In the year 1999, what is the difference between the Value added (current US$) of Chad and Value added (current US$) of Macao?
Your answer should be very brief. -3.23e+08. In the year 1999, what is the difference between the Value added (current US$) in Chad and Value added (current US$) in Venezuela?
Your response must be concise. -1.72e+1. In the year 1999, what is the difference between the Value added (current US$) of Macao and Value added (current US$) of Venezuela?
Make the answer very short. -1.69e+1. In the year 2000, what is the difference between the Value added (current US$) of Burundi and Value added (current US$) of Chad?
Keep it short and to the point. -2.41e+07. In the year 2000, what is the difference between the Value added (current US$) in Burundi and Value added (current US$) in Macao?
Keep it short and to the point. -4.02e+08. In the year 2000, what is the difference between the Value added (current US$) of Burundi and Value added (current US$) of Venezuela?
Make the answer very short. -2.16e+1. In the year 2000, what is the difference between the Value added (current US$) in Chad and Value added (current US$) in Macao?
Give a very brief answer. -3.78e+08. In the year 2000, what is the difference between the Value added (current US$) in Chad and Value added (current US$) in Venezuela?
Ensure brevity in your answer.  -2.16e+1. In the year 2000, what is the difference between the Value added (current US$) of Macao and Value added (current US$) of Venezuela?
Ensure brevity in your answer.  -2.12e+1. In the year 2001, what is the difference between the Value added (current US$) in Burundi and Value added (current US$) in Chad?
Your response must be concise. -6.17e+07. In the year 2001, what is the difference between the Value added (current US$) of Burundi and Value added (current US$) of Macao?
Provide a succinct answer. -3.09e+08. In the year 2001, what is the difference between the Value added (current US$) in Burundi and Value added (current US$) in Venezuela?
Keep it short and to the point. -2.08e+1. In the year 2001, what is the difference between the Value added (current US$) in Chad and Value added (current US$) in Macao?
Your answer should be very brief. -2.48e+08. In the year 2001, what is the difference between the Value added (current US$) in Chad and Value added (current US$) in Venezuela?
Ensure brevity in your answer.  -2.07e+1. In the year 2001, what is the difference between the Value added (current US$) of Macao and Value added (current US$) of Venezuela?
Offer a very short reply. -2.05e+1. In the year 2002, what is the difference between the Value added (current US$) in Burundi and Value added (current US$) in Chad?
Give a very brief answer. -8.86e+07. In the year 2002, what is the difference between the Value added (current US$) of Burundi and Value added (current US$) of Macao?
Provide a succinct answer. -2.91e+08. In the year 2002, what is the difference between the Value added (current US$) in Burundi and Value added (current US$) in Venezuela?
Ensure brevity in your answer.  -1.52e+1. In the year 2002, what is the difference between the Value added (current US$) in Chad and Value added (current US$) in Macao?
Your response must be concise. -2.02e+08. In the year 2002, what is the difference between the Value added (current US$) of Chad and Value added (current US$) of Venezuela?
Provide a short and direct response. -1.51e+1. In the year 2002, what is the difference between the Value added (current US$) in Macao and Value added (current US$) in Venezuela?
Your answer should be compact. -1.49e+1. In the year 2003, what is the difference between the Value added (current US$) of Burundi and Value added (current US$) of Chad?
Your answer should be very brief. -1.23e+08. In the year 2003, what is the difference between the Value added (current US$) of Burundi and Value added (current US$) of Macao?
Make the answer very short. -2.89e+08. In the year 2003, what is the difference between the Value added (current US$) of Burundi and Value added (current US$) of Venezuela?
Ensure brevity in your answer.  -1.42e+1. In the year 2003, what is the difference between the Value added (current US$) of Chad and Value added (current US$) of Macao?
Your response must be concise. -1.65e+08. In the year 2003, what is the difference between the Value added (current US$) of Chad and Value added (current US$) of Venezuela?
Your answer should be very brief. -1.41e+1. In the year 2003, what is the difference between the Value added (current US$) in Macao and Value added (current US$) in Venezuela?
Offer a very short reply. -1.39e+1. In the year 2004, what is the difference between the Value added (current US$) in Burundi and Value added (current US$) in Chad?
Keep it short and to the point. -1.17e+08. In the year 2004, what is the difference between the Value added (current US$) in Burundi and Value added (current US$) in Macao?
Your answer should be compact. -2.80e+08. In the year 2004, what is the difference between the Value added (current US$) of Burundi and Value added (current US$) of Venezuela?
Make the answer very short. -1.84e+1. In the year 2004, what is the difference between the Value added (current US$) of Chad and Value added (current US$) of Macao?
Give a very brief answer. -1.63e+08. In the year 2004, what is the difference between the Value added (current US$) in Chad and Value added (current US$) in Venezuela?
Offer a very short reply. -1.83e+1. In the year 2004, what is the difference between the Value added (current US$) of Macao and Value added (current US$) of Venezuela?
Your answer should be compact. -1.81e+1. What is the ratio of the Value added (current US$) in Burundi in 1997 to that in 1998?
Give a very brief answer. 1.03. What is the ratio of the Value added (current US$) in Chad in 1997 to that in 1998?
Give a very brief answer. 0.95. What is the ratio of the Value added (current US$) of Macao in 1997 to that in 1998?
Make the answer very short. 0.97. What is the ratio of the Value added (current US$) of Venezuela in 1997 to that in 1998?
Give a very brief answer. 1.04. What is the ratio of the Value added (current US$) in Burundi in 1997 to that in 1999?
Provide a succinct answer. 1.04. What is the ratio of the Value added (current US$) of Chad in 1997 to that in 1999?
Make the answer very short. 1.19. What is the ratio of the Value added (current US$) of Macao in 1997 to that in 1999?
Provide a short and direct response. 1. What is the ratio of the Value added (current US$) of Venezuela in 1997 to that in 1999?
Provide a succinct answer. 1.05. What is the ratio of the Value added (current US$) in Burundi in 1997 to that in 2000?
Your answer should be compact. 1. What is the ratio of the Value added (current US$) in Chad in 1997 to that in 2000?
Provide a short and direct response. 1.5. What is the ratio of the Value added (current US$) of Macao in 1997 to that in 2000?
Offer a terse response. 0.95. What is the ratio of the Value added (current US$) in Venezuela in 1997 to that in 2000?
Make the answer very short. 0.84. What is the ratio of the Value added (current US$) of Chad in 1997 to that in 2001?
Offer a terse response. 1.13. What is the ratio of the Value added (current US$) of Macao in 1997 to that in 2001?
Your answer should be compact. 1.17. What is the ratio of the Value added (current US$) in Venezuela in 1997 to that in 2001?
Give a very brief answer. 0.87. What is the ratio of the Value added (current US$) in Burundi in 1997 to that in 2002?
Make the answer very short. 1.04. What is the ratio of the Value added (current US$) of Macao in 1997 to that in 2002?
Keep it short and to the point. 1.24. What is the ratio of the Value added (current US$) in Venezuela in 1997 to that in 2002?
Give a very brief answer. 1.19. What is the ratio of the Value added (current US$) of Burundi in 1997 to that in 2003?
Offer a very short reply. 1.09. What is the ratio of the Value added (current US$) of Chad in 1997 to that in 2003?
Your answer should be very brief. 0.85. What is the ratio of the Value added (current US$) of Macao in 1997 to that in 2003?
Your response must be concise. 1.27. What is the ratio of the Value added (current US$) of Venezuela in 1997 to that in 2003?
Keep it short and to the point. 1.27. What is the ratio of the Value added (current US$) of Burundi in 1997 to that in 2004?
Provide a succinct answer. 0.9. What is the ratio of the Value added (current US$) of Chad in 1997 to that in 2004?
Your response must be concise. 0.8. What is the ratio of the Value added (current US$) of Macao in 1997 to that in 2004?
Your answer should be compact. 1.23. What is the ratio of the Value added (current US$) of Venezuela in 1997 to that in 2004?
Your answer should be compact. 0.98. What is the ratio of the Value added (current US$) of Chad in 1998 to that in 1999?
Ensure brevity in your answer.  1.25. What is the ratio of the Value added (current US$) in Macao in 1998 to that in 1999?
Give a very brief answer. 1.03. What is the ratio of the Value added (current US$) of Burundi in 1998 to that in 2000?
Make the answer very short. 0.97. What is the ratio of the Value added (current US$) in Chad in 1998 to that in 2000?
Provide a succinct answer. 1.58. What is the ratio of the Value added (current US$) of Macao in 1998 to that in 2000?
Your answer should be compact. 0.98. What is the ratio of the Value added (current US$) in Venezuela in 1998 to that in 2000?
Keep it short and to the point. 0.8. What is the ratio of the Value added (current US$) in Burundi in 1998 to that in 2001?
Make the answer very short. 0.96. What is the ratio of the Value added (current US$) in Chad in 1998 to that in 2001?
Offer a terse response. 1.19. What is the ratio of the Value added (current US$) in Macao in 1998 to that in 2001?
Give a very brief answer. 1.2. What is the ratio of the Value added (current US$) of Venezuela in 1998 to that in 2001?
Offer a terse response. 0.83. What is the ratio of the Value added (current US$) in Burundi in 1998 to that in 2002?
Your answer should be compact. 1.01. What is the ratio of the Value added (current US$) in Chad in 1998 to that in 2002?
Keep it short and to the point. 1.04. What is the ratio of the Value added (current US$) in Macao in 1998 to that in 2002?
Your answer should be very brief. 1.28. What is the ratio of the Value added (current US$) in Venezuela in 1998 to that in 2002?
Give a very brief answer. 1.14. What is the ratio of the Value added (current US$) in Burundi in 1998 to that in 2003?
Make the answer very short. 1.06. What is the ratio of the Value added (current US$) in Chad in 1998 to that in 2003?
Provide a short and direct response. 0.9. What is the ratio of the Value added (current US$) of Macao in 1998 to that in 2003?
Your answer should be very brief. 1.3. What is the ratio of the Value added (current US$) of Venezuela in 1998 to that in 2003?
Offer a terse response. 1.21. What is the ratio of the Value added (current US$) of Burundi in 1998 to that in 2004?
Provide a short and direct response. 0.88. What is the ratio of the Value added (current US$) in Chad in 1998 to that in 2004?
Provide a short and direct response. 0.85. What is the ratio of the Value added (current US$) of Macao in 1998 to that in 2004?
Make the answer very short. 1.27. What is the ratio of the Value added (current US$) in Venezuela in 1998 to that in 2004?
Your response must be concise. 0.94. What is the ratio of the Value added (current US$) in Burundi in 1999 to that in 2000?
Make the answer very short. 0.96. What is the ratio of the Value added (current US$) of Chad in 1999 to that in 2000?
Make the answer very short. 1.26. What is the ratio of the Value added (current US$) of Macao in 1999 to that in 2000?
Provide a short and direct response. 0.95. What is the ratio of the Value added (current US$) of Venezuela in 1999 to that in 2000?
Provide a succinct answer. 0.8. What is the ratio of the Value added (current US$) in Burundi in 1999 to that in 2001?
Offer a very short reply. 0.95. What is the ratio of the Value added (current US$) in Chad in 1999 to that in 2001?
Your answer should be compact. 0.95. What is the ratio of the Value added (current US$) of Macao in 1999 to that in 2001?
Give a very brief answer. 1.17. What is the ratio of the Value added (current US$) of Venezuela in 1999 to that in 2001?
Keep it short and to the point. 0.83. What is the ratio of the Value added (current US$) of Burundi in 1999 to that in 2002?
Offer a terse response. 1. What is the ratio of the Value added (current US$) of Macao in 1999 to that in 2002?
Make the answer very short. 1.24. What is the ratio of the Value added (current US$) of Venezuela in 1999 to that in 2002?
Give a very brief answer. 1.14. What is the ratio of the Value added (current US$) in Burundi in 1999 to that in 2003?
Your answer should be compact. 1.05. What is the ratio of the Value added (current US$) of Chad in 1999 to that in 2003?
Keep it short and to the point. 0.71. What is the ratio of the Value added (current US$) of Macao in 1999 to that in 2003?
Offer a very short reply. 1.26. What is the ratio of the Value added (current US$) in Venezuela in 1999 to that in 2003?
Provide a short and direct response. 1.21. What is the ratio of the Value added (current US$) in Burundi in 1999 to that in 2004?
Offer a terse response. 0.87. What is the ratio of the Value added (current US$) in Chad in 1999 to that in 2004?
Offer a very short reply. 0.68. What is the ratio of the Value added (current US$) in Macao in 1999 to that in 2004?
Make the answer very short. 1.23. What is the ratio of the Value added (current US$) of Venezuela in 1999 to that in 2004?
Your answer should be very brief. 0.94. What is the ratio of the Value added (current US$) in Burundi in 2000 to that in 2001?
Provide a short and direct response. 0.99. What is the ratio of the Value added (current US$) in Chad in 2000 to that in 2001?
Provide a succinct answer. 0.76. What is the ratio of the Value added (current US$) of Macao in 2000 to that in 2001?
Ensure brevity in your answer.  1.23. What is the ratio of the Value added (current US$) in Venezuela in 2000 to that in 2001?
Keep it short and to the point. 1.04. What is the ratio of the Value added (current US$) of Chad in 2000 to that in 2002?
Your answer should be very brief. 0.66. What is the ratio of the Value added (current US$) of Macao in 2000 to that in 2002?
Your answer should be compact. 1.3. What is the ratio of the Value added (current US$) in Venezuela in 2000 to that in 2002?
Provide a short and direct response. 1.42. What is the ratio of the Value added (current US$) in Burundi in 2000 to that in 2003?
Your answer should be very brief. 1.1. What is the ratio of the Value added (current US$) in Chad in 2000 to that in 2003?
Make the answer very short. 0.57. What is the ratio of the Value added (current US$) of Macao in 2000 to that in 2003?
Your answer should be compact. 1.32. What is the ratio of the Value added (current US$) in Venezuela in 2000 to that in 2003?
Your answer should be very brief. 1.52. What is the ratio of the Value added (current US$) in Burundi in 2000 to that in 2004?
Your answer should be compact. 0.91. What is the ratio of the Value added (current US$) of Chad in 2000 to that in 2004?
Give a very brief answer. 0.54. What is the ratio of the Value added (current US$) of Macao in 2000 to that in 2004?
Offer a very short reply. 1.29. What is the ratio of the Value added (current US$) of Venezuela in 2000 to that in 2004?
Ensure brevity in your answer.  1.17. What is the ratio of the Value added (current US$) in Burundi in 2001 to that in 2002?
Make the answer very short. 1.05. What is the ratio of the Value added (current US$) in Chad in 2001 to that in 2002?
Your answer should be compact. 0.87. What is the ratio of the Value added (current US$) in Macao in 2001 to that in 2002?
Your answer should be very brief. 1.06. What is the ratio of the Value added (current US$) of Venezuela in 2001 to that in 2002?
Ensure brevity in your answer.  1.37. What is the ratio of the Value added (current US$) in Burundi in 2001 to that in 2003?
Offer a terse response. 1.11. What is the ratio of the Value added (current US$) of Macao in 2001 to that in 2003?
Your answer should be compact. 1.08. What is the ratio of the Value added (current US$) in Venezuela in 2001 to that in 2003?
Provide a succinct answer. 1.46. What is the ratio of the Value added (current US$) of Burundi in 2001 to that in 2004?
Your answer should be very brief. 0.91. What is the ratio of the Value added (current US$) of Chad in 2001 to that in 2004?
Your answer should be compact. 0.71. What is the ratio of the Value added (current US$) in Macao in 2001 to that in 2004?
Give a very brief answer. 1.05. What is the ratio of the Value added (current US$) in Venezuela in 2001 to that in 2004?
Keep it short and to the point. 1.13. What is the ratio of the Value added (current US$) of Burundi in 2002 to that in 2003?
Ensure brevity in your answer.  1.06. What is the ratio of the Value added (current US$) of Chad in 2002 to that in 2003?
Keep it short and to the point. 0.86. What is the ratio of the Value added (current US$) of Macao in 2002 to that in 2003?
Ensure brevity in your answer.  1.02. What is the ratio of the Value added (current US$) in Venezuela in 2002 to that in 2003?
Give a very brief answer. 1.07. What is the ratio of the Value added (current US$) in Burundi in 2002 to that in 2004?
Provide a succinct answer. 0.87. What is the ratio of the Value added (current US$) of Chad in 2002 to that in 2004?
Your response must be concise. 0.81. What is the ratio of the Value added (current US$) in Venezuela in 2002 to that in 2004?
Offer a terse response. 0.83. What is the ratio of the Value added (current US$) in Burundi in 2003 to that in 2004?
Provide a short and direct response. 0.83. What is the ratio of the Value added (current US$) in Chad in 2003 to that in 2004?
Give a very brief answer. 0.95. What is the ratio of the Value added (current US$) of Macao in 2003 to that in 2004?
Keep it short and to the point. 0.98. What is the ratio of the Value added (current US$) in Venezuela in 2003 to that in 2004?
Make the answer very short. 0.77. What is the difference between the highest and the second highest Value added (current US$) of Burundi?
Offer a very short reply. 9.02e+06. What is the difference between the highest and the second highest Value added (current US$) of Chad?
Offer a very short reply. 1.17e+07. What is the difference between the highest and the second highest Value added (current US$) of Macao?
Offer a terse response. 9.37e+06. What is the difference between the highest and the second highest Value added (current US$) of Venezuela?
Make the answer very short. 8.25e+08. What is the difference between the highest and the lowest Value added (current US$) of Burundi?
Ensure brevity in your answer.  1.82e+07. What is the difference between the highest and the lowest Value added (current US$) in Chad?
Offer a terse response. 1.03e+08. What is the difference between the highest and the lowest Value added (current US$) of Macao?
Your answer should be very brief. 1.22e+08. What is the difference between the highest and the lowest Value added (current US$) of Venezuela?
Offer a very short reply. 7.39e+09. 